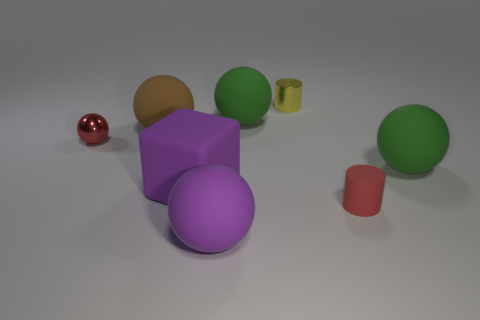Subtract all green spheres. How many spheres are left? 3 Subtract all green balls. How many balls are left? 3 Subtract all blocks. How many objects are left? 7 Subtract all gray cylinders. How many purple spheres are left? 1 Add 2 large brown things. How many large brown things exist? 3 Add 1 small balls. How many objects exist? 9 Subtract 0 brown blocks. How many objects are left? 8 Subtract 2 cylinders. How many cylinders are left? 0 Subtract all gray blocks. Subtract all blue cylinders. How many blocks are left? 1 Subtract all large purple balls. Subtract all small matte objects. How many objects are left? 6 